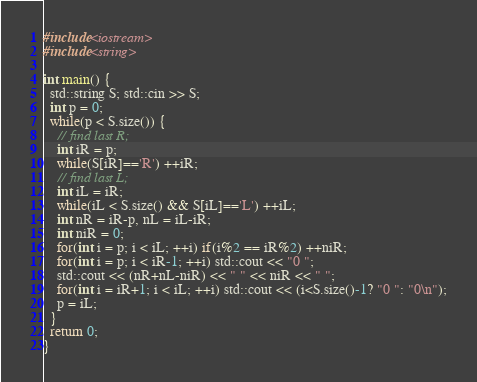Convert code to text. <code><loc_0><loc_0><loc_500><loc_500><_C++_>#include<iostream>
#include<string>

int main() {
  std::string S; std::cin >> S;
  int p = 0;
  while(p < S.size()) {
    // find last R;
    int iR = p;
    while(S[iR]=='R') ++iR;
    // find last L;
    int iL = iR;
    while(iL < S.size() && S[iL]=='L') ++iL;
    int nR = iR-p, nL = iL-iR;
    int niR = 0;
    for(int i = p; i < iL; ++i) if(i%2 == iR%2) ++niR;
    for(int i = p; i < iR-1; ++i) std::cout << "0 ";
    std::cout << (nR+nL-niR) << " " << niR << " ";
    for(int i = iR+1; i < iL; ++i) std::cout << (i<S.size()-1? "0 ": "0\n");
    p = iL;
  }
  return 0;
}
</code> 